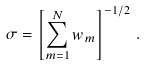<formula> <loc_0><loc_0><loc_500><loc_500>\sigma = \left [ \sum ^ { N } _ { m = 1 } w _ { m } \right ] ^ { - 1 / 2 } \, .</formula> 